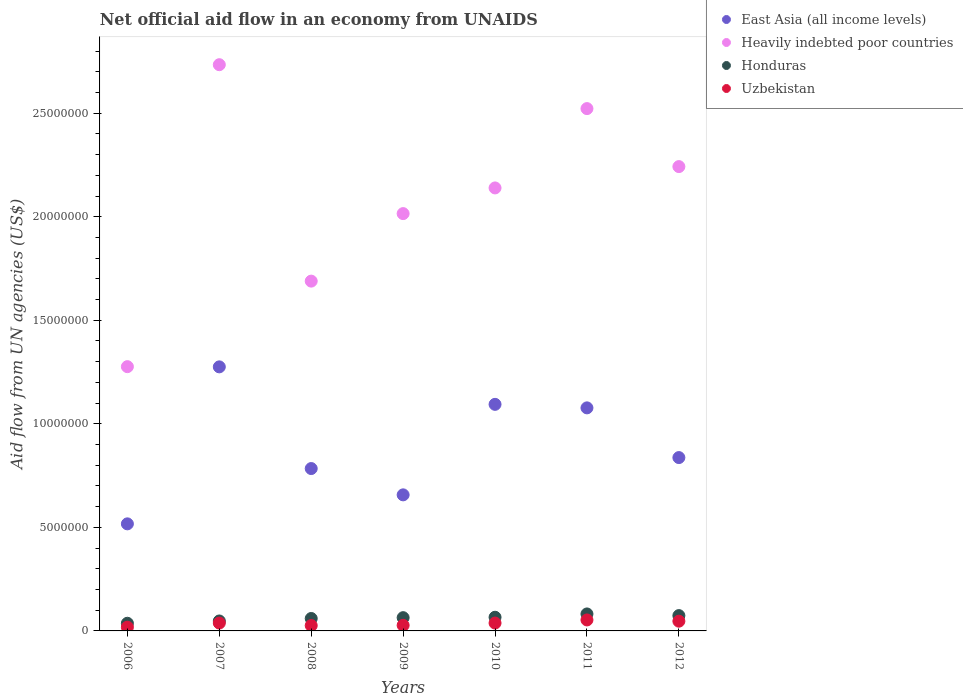Is the number of dotlines equal to the number of legend labels?
Offer a terse response. Yes. What is the net official aid flow in East Asia (all income levels) in 2008?
Offer a very short reply. 7.84e+06. Across all years, what is the maximum net official aid flow in Honduras?
Your answer should be very brief. 8.20e+05. Across all years, what is the minimum net official aid flow in Uzbekistan?
Provide a short and direct response. 1.80e+05. In which year was the net official aid flow in East Asia (all income levels) maximum?
Offer a terse response. 2007. What is the total net official aid flow in Honduras in the graph?
Your answer should be compact. 4.31e+06. What is the difference between the net official aid flow in Uzbekistan in 2008 and that in 2012?
Keep it short and to the point. -2.10e+05. What is the difference between the net official aid flow in Uzbekistan in 2011 and the net official aid flow in East Asia (all income levels) in 2009?
Your answer should be very brief. -6.04e+06. What is the average net official aid flow in Honduras per year?
Keep it short and to the point. 6.16e+05. In the year 2008, what is the difference between the net official aid flow in East Asia (all income levels) and net official aid flow in Honduras?
Ensure brevity in your answer.  7.24e+06. What is the ratio of the net official aid flow in Uzbekistan in 2010 to that in 2011?
Provide a short and direct response. 0.72. What is the difference between the highest and the lowest net official aid flow in East Asia (all income levels)?
Offer a terse response. 7.58e+06. In how many years, is the net official aid flow in Heavily indebted poor countries greater than the average net official aid flow in Heavily indebted poor countries taken over all years?
Offer a very short reply. 4. Is it the case that in every year, the sum of the net official aid flow in East Asia (all income levels) and net official aid flow in Honduras  is greater than the sum of net official aid flow in Heavily indebted poor countries and net official aid flow in Uzbekistan?
Offer a very short reply. Yes. Is it the case that in every year, the sum of the net official aid flow in Honduras and net official aid flow in East Asia (all income levels)  is greater than the net official aid flow in Uzbekistan?
Your answer should be compact. Yes. Does the net official aid flow in Heavily indebted poor countries monotonically increase over the years?
Make the answer very short. No. Is the net official aid flow in East Asia (all income levels) strictly less than the net official aid flow in Honduras over the years?
Provide a short and direct response. No. How many dotlines are there?
Offer a terse response. 4. How many years are there in the graph?
Ensure brevity in your answer.  7. Are the values on the major ticks of Y-axis written in scientific E-notation?
Provide a succinct answer. No. Does the graph contain any zero values?
Your answer should be very brief. No. Does the graph contain grids?
Give a very brief answer. No. Where does the legend appear in the graph?
Offer a very short reply. Top right. How many legend labels are there?
Your answer should be compact. 4. What is the title of the graph?
Provide a succinct answer. Net official aid flow in an economy from UNAIDS. Does "Central Europe" appear as one of the legend labels in the graph?
Keep it short and to the point. No. What is the label or title of the X-axis?
Make the answer very short. Years. What is the label or title of the Y-axis?
Offer a terse response. Aid flow from UN agencies (US$). What is the Aid flow from UN agencies (US$) in East Asia (all income levels) in 2006?
Keep it short and to the point. 5.17e+06. What is the Aid flow from UN agencies (US$) in Heavily indebted poor countries in 2006?
Your response must be concise. 1.28e+07. What is the Aid flow from UN agencies (US$) in Honduras in 2006?
Provide a succinct answer. 3.70e+05. What is the Aid flow from UN agencies (US$) in East Asia (all income levels) in 2007?
Ensure brevity in your answer.  1.28e+07. What is the Aid flow from UN agencies (US$) in Heavily indebted poor countries in 2007?
Offer a very short reply. 2.73e+07. What is the Aid flow from UN agencies (US$) in Honduras in 2007?
Your response must be concise. 4.80e+05. What is the Aid flow from UN agencies (US$) of East Asia (all income levels) in 2008?
Ensure brevity in your answer.  7.84e+06. What is the Aid flow from UN agencies (US$) in Heavily indebted poor countries in 2008?
Your answer should be compact. 1.69e+07. What is the Aid flow from UN agencies (US$) in Uzbekistan in 2008?
Ensure brevity in your answer.  2.60e+05. What is the Aid flow from UN agencies (US$) of East Asia (all income levels) in 2009?
Your response must be concise. 6.57e+06. What is the Aid flow from UN agencies (US$) of Heavily indebted poor countries in 2009?
Provide a short and direct response. 2.02e+07. What is the Aid flow from UN agencies (US$) in Honduras in 2009?
Your response must be concise. 6.40e+05. What is the Aid flow from UN agencies (US$) in Uzbekistan in 2009?
Provide a succinct answer. 2.70e+05. What is the Aid flow from UN agencies (US$) in East Asia (all income levels) in 2010?
Your answer should be compact. 1.09e+07. What is the Aid flow from UN agencies (US$) of Heavily indebted poor countries in 2010?
Provide a succinct answer. 2.14e+07. What is the Aid flow from UN agencies (US$) of Uzbekistan in 2010?
Give a very brief answer. 3.80e+05. What is the Aid flow from UN agencies (US$) in East Asia (all income levels) in 2011?
Ensure brevity in your answer.  1.08e+07. What is the Aid flow from UN agencies (US$) in Heavily indebted poor countries in 2011?
Offer a very short reply. 2.52e+07. What is the Aid flow from UN agencies (US$) in Honduras in 2011?
Your answer should be very brief. 8.20e+05. What is the Aid flow from UN agencies (US$) of Uzbekistan in 2011?
Ensure brevity in your answer.  5.30e+05. What is the Aid flow from UN agencies (US$) in East Asia (all income levels) in 2012?
Keep it short and to the point. 8.37e+06. What is the Aid flow from UN agencies (US$) of Heavily indebted poor countries in 2012?
Ensure brevity in your answer.  2.24e+07. What is the Aid flow from UN agencies (US$) of Honduras in 2012?
Provide a short and direct response. 7.40e+05. Across all years, what is the maximum Aid flow from UN agencies (US$) in East Asia (all income levels)?
Offer a terse response. 1.28e+07. Across all years, what is the maximum Aid flow from UN agencies (US$) of Heavily indebted poor countries?
Your response must be concise. 2.73e+07. Across all years, what is the maximum Aid flow from UN agencies (US$) in Honduras?
Provide a succinct answer. 8.20e+05. Across all years, what is the maximum Aid flow from UN agencies (US$) of Uzbekistan?
Provide a succinct answer. 5.30e+05. Across all years, what is the minimum Aid flow from UN agencies (US$) of East Asia (all income levels)?
Your response must be concise. 5.17e+06. Across all years, what is the minimum Aid flow from UN agencies (US$) in Heavily indebted poor countries?
Offer a very short reply. 1.28e+07. Across all years, what is the minimum Aid flow from UN agencies (US$) of Honduras?
Give a very brief answer. 3.70e+05. Across all years, what is the minimum Aid flow from UN agencies (US$) in Uzbekistan?
Give a very brief answer. 1.80e+05. What is the total Aid flow from UN agencies (US$) in East Asia (all income levels) in the graph?
Provide a succinct answer. 6.24e+07. What is the total Aid flow from UN agencies (US$) in Heavily indebted poor countries in the graph?
Provide a short and direct response. 1.46e+08. What is the total Aid flow from UN agencies (US$) of Honduras in the graph?
Give a very brief answer. 4.31e+06. What is the total Aid flow from UN agencies (US$) of Uzbekistan in the graph?
Provide a short and direct response. 2.47e+06. What is the difference between the Aid flow from UN agencies (US$) of East Asia (all income levels) in 2006 and that in 2007?
Provide a succinct answer. -7.58e+06. What is the difference between the Aid flow from UN agencies (US$) of Heavily indebted poor countries in 2006 and that in 2007?
Give a very brief answer. -1.46e+07. What is the difference between the Aid flow from UN agencies (US$) in East Asia (all income levels) in 2006 and that in 2008?
Offer a terse response. -2.67e+06. What is the difference between the Aid flow from UN agencies (US$) in Heavily indebted poor countries in 2006 and that in 2008?
Your answer should be very brief. -4.13e+06. What is the difference between the Aid flow from UN agencies (US$) of Honduras in 2006 and that in 2008?
Offer a very short reply. -2.30e+05. What is the difference between the Aid flow from UN agencies (US$) of Uzbekistan in 2006 and that in 2008?
Your answer should be compact. -8.00e+04. What is the difference between the Aid flow from UN agencies (US$) of East Asia (all income levels) in 2006 and that in 2009?
Provide a short and direct response. -1.40e+06. What is the difference between the Aid flow from UN agencies (US$) in Heavily indebted poor countries in 2006 and that in 2009?
Your answer should be compact. -7.39e+06. What is the difference between the Aid flow from UN agencies (US$) of East Asia (all income levels) in 2006 and that in 2010?
Give a very brief answer. -5.77e+06. What is the difference between the Aid flow from UN agencies (US$) of Heavily indebted poor countries in 2006 and that in 2010?
Provide a short and direct response. -8.63e+06. What is the difference between the Aid flow from UN agencies (US$) of Honduras in 2006 and that in 2010?
Provide a short and direct response. -2.90e+05. What is the difference between the Aid flow from UN agencies (US$) of East Asia (all income levels) in 2006 and that in 2011?
Your answer should be very brief. -5.60e+06. What is the difference between the Aid flow from UN agencies (US$) in Heavily indebted poor countries in 2006 and that in 2011?
Keep it short and to the point. -1.25e+07. What is the difference between the Aid flow from UN agencies (US$) in Honduras in 2006 and that in 2011?
Provide a short and direct response. -4.50e+05. What is the difference between the Aid flow from UN agencies (US$) in Uzbekistan in 2006 and that in 2011?
Your answer should be compact. -3.50e+05. What is the difference between the Aid flow from UN agencies (US$) of East Asia (all income levels) in 2006 and that in 2012?
Offer a terse response. -3.20e+06. What is the difference between the Aid flow from UN agencies (US$) in Heavily indebted poor countries in 2006 and that in 2012?
Your answer should be very brief. -9.66e+06. What is the difference between the Aid flow from UN agencies (US$) in Honduras in 2006 and that in 2012?
Provide a succinct answer. -3.70e+05. What is the difference between the Aid flow from UN agencies (US$) of East Asia (all income levels) in 2007 and that in 2008?
Your response must be concise. 4.91e+06. What is the difference between the Aid flow from UN agencies (US$) of Heavily indebted poor countries in 2007 and that in 2008?
Offer a very short reply. 1.04e+07. What is the difference between the Aid flow from UN agencies (US$) of Honduras in 2007 and that in 2008?
Offer a very short reply. -1.20e+05. What is the difference between the Aid flow from UN agencies (US$) of Uzbekistan in 2007 and that in 2008?
Provide a succinct answer. 1.20e+05. What is the difference between the Aid flow from UN agencies (US$) of East Asia (all income levels) in 2007 and that in 2009?
Give a very brief answer. 6.18e+06. What is the difference between the Aid flow from UN agencies (US$) of Heavily indebted poor countries in 2007 and that in 2009?
Provide a short and direct response. 7.19e+06. What is the difference between the Aid flow from UN agencies (US$) of Honduras in 2007 and that in 2009?
Give a very brief answer. -1.60e+05. What is the difference between the Aid flow from UN agencies (US$) of Uzbekistan in 2007 and that in 2009?
Ensure brevity in your answer.  1.10e+05. What is the difference between the Aid flow from UN agencies (US$) of East Asia (all income levels) in 2007 and that in 2010?
Provide a short and direct response. 1.81e+06. What is the difference between the Aid flow from UN agencies (US$) of Heavily indebted poor countries in 2007 and that in 2010?
Provide a short and direct response. 5.95e+06. What is the difference between the Aid flow from UN agencies (US$) in Uzbekistan in 2007 and that in 2010?
Give a very brief answer. 0. What is the difference between the Aid flow from UN agencies (US$) of East Asia (all income levels) in 2007 and that in 2011?
Keep it short and to the point. 1.98e+06. What is the difference between the Aid flow from UN agencies (US$) of Heavily indebted poor countries in 2007 and that in 2011?
Ensure brevity in your answer.  2.12e+06. What is the difference between the Aid flow from UN agencies (US$) in East Asia (all income levels) in 2007 and that in 2012?
Your response must be concise. 4.38e+06. What is the difference between the Aid flow from UN agencies (US$) in Heavily indebted poor countries in 2007 and that in 2012?
Make the answer very short. 4.92e+06. What is the difference between the Aid flow from UN agencies (US$) of Honduras in 2007 and that in 2012?
Give a very brief answer. -2.60e+05. What is the difference between the Aid flow from UN agencies (US$) of Uzbekistan in 2007 and that in 2012?
Offer a terse response. -9.00e+04. What is the difference between the Aid flow from UN agencies (US$) of East Asia (all income levels) in 2008 and that in 2009?
Offer a very short reply. 1.27e+06. What is the difference between the Aid flow from UN agencies (US$) of Heavily indebted poor countries in 2008 and that in 2009?
Provide a succinct answer. -3.26e+06. What is the difference between the Aid flow from UN agencies (US$) in East Asia (all income levels) in 2008 and that in 2010?
Offer a terse response. -3.10e+06. What is the difference between the Aid flow from UN agencies (US$) in Heavily indebted poor countries in 2008 and that in 2010?
Offer a terse response. -4.50e+06. What is the difference between the Aid flow from UN agencies (US$) in Uzbekistan in 2008 and that in 2010?
Offer a terse response. -1.20e+05. What is the difference between the Aid flow from UN agencies (US$) in East Asia (all income levels) in 2008 and that in 2011?
Provide a short and direct response. -2.93e+06. What is the difference between the Aid flow from UN agencies (US$) of Heavily indebted poor countries in 2008 and that in 2011?
Keep it short and to the point. -8.33e+06. What is the difference between the Aid flow from UN agencies (US$) in Honduras in 2008 and that in 2011?
Make the answer very short. -2.20e+05. What is the difference between the Aid flow from UN agencies (US$) in Uzbekistan in 2008 and that in 2011?
Give a very brief answer. -2.70e+05. What is the difference between the Aid flow from UN agencies (US$) in East Asia (all income levels) in 2008 and that in 2012?
Offer a very short reply. -5.30e+05. What is the difference between the Aid flow from UN agencies (US$) of Heavily indebted poor countries in 2008 and that in 2012?
Keep it short and to the point. -5.53e+06. What is the difference between the Aid flow from UN agencies (US$) in East Asia (all income levels) in 2009 and that in 2010?
Provide a succinct answer. -4.37e+06. What is the difference between the Aid flow from UN agencies (US$) in Heavily indebted poor countries in 2009 and that in 2010?
Offer a very short reply. -1.24e+06. What is the difference between the Aid flow from UN agencies (US$) of Honduras in 2009 and that in 2010?
Provide a short and direct response. -2.00e+04. What is the difference between the Aid flow from UN agencies (US$) of Uzbekistan in 2009 and that in 2010?
Your response must be concise. -1.10e+05. What is the difference between the Aid flow from UN agencies (US$) in East Asia (all income levels) in 2009 and that in 2011?
Offer a very short reply. -4.20e+06. What is the difference between the Aid flow from UN agencies (US$) in Heavily indebted poor countries in 2009 and that in 2011?
Make the answer very short. -5.07e+06. What is the difference between the Aid flow from UN agencies (US$) in Honduras in 2009 and that in 2011?
Your answer should be compact. -1.80e+05. What is the difference between the Aid flow from UN agencies (US$) of Uzbekistan in 2009 and that in 2011?
Give a very brief answer. -2.60e+05. What is the difference between the Aid flow from UN agencies (US$) of East Asia (all income levels) in 2009 and that in 2012?
Make the answer very short. -1.80e+06. What is the difference between the Aid flow from UN agencies (US$) in Heavily indebted poor countries in 2009 and that in 2012?
Offer a very short reply. -2.27e+06. What is the difference between the Aid flow from UN agencies (US$) of Honduras in 2009 and that in 2012?
Your answer should be compact. -1.00e+05. What is the difference between the Aid flow from UN agencies (US$) of Heavily indebted poor countries in 2010 and that in 2011?
Your response must be concise. -3.83e+06. What is the difference between the Aid flow from UN agencies (US$) in East Asia (all income levels) in 2010 and that in 2012?
Your answer should be compact. 2.57e+06. What is the difference between the Aid flow from UN agencies (US$) of Heavily indebted poor countries in 2010 and that in 2012?
Offer a very short reply. -1.03e+06. What is the difference between the Aid flow from UN agencies (US$) of East Asia (all income levels) in 2011 and that in 2012?
Make the answer very short. 2.40e+06. What is the difference between the Aid flow from UN agencies (US$) of Heavily indebted poor countries in 2011 and that in 2012?
Your response must be concise. 2.80e+06. What is the difference between the Aid flow from UN agencies (US$) of Uzbekistan in 2011 and that in 2012?
Provide a short and direct response. 6.00e+04. What is the difference between the Aid flow from UN agencies (US$) of East Asia (all income levels) in 2006 and the Aid flow from UN agencies (US$) of Heavily indebted poor countries in 2007?
Make the answer very short. -2.22e+07. What is the difference between the Aid flow from UN agencies (US$) of East Asia (all income levels) in 2006 and the Aid flow from UN agencies (US$) of Honduras in 2007?
Your answer should be very brief. 4.69e+06. What is the difference between the Aid flow from UN agencies (US$) in East Asia (all income levels) in 2006 and the Aid flow from UN agencies (US$) in Uzbekistan in 2007?
Give a very brief answer. 4.79e+06. What is the difference between the Aid flow from UN agencies (US$) in Heavily indebted poor countries in 2006 and the Aid flow from UN agencies (US$) in Honduras in 2007?
Your answer should be compact. 1.23e+07. What is the difference between the Aid flow from UN agencies (US$) of Heavily indebted poor countries in 2006 and the Aid flow from UN agencies (US$) of Uzbekistan in 2007?
Offer a very short reply. 1.24e+07. What is the difference between the Aid flow from UN agencies (US$) in Honduras in 2006 and the Aid flow from UN agencies (US$) in Uzbekistan in 2007?
Keep it short and to the point. -10000. What is the difference between the Aid flow from UN agencies (US$) of East Asia (all income levels) in 2006 and the Aid flow from UN agencies (US$) of Heavily indebted poor countries in 2008?
Ensure brevity in your answer.  -1.17e+07. What is the difference between the Aid flow from UN agencies (US$) in East Asia (all income levels) in 2006 and the Aid flow from UN agencies (US$) in Honduras in 2008?
Ensure brevity in your answer.  4.57e+06. What is the difference between the Aid flow from UN agencies (US$) of East Asia (all income levels) in 2006 and the Aid flow from UN agencies (US$) of Uzbekistan in 2008?
Make the answer very short. 4.91e+06. What is the difference between the Aid flow from UN agencies (US$) of Heavily indebted poor countries in 2006 and the Aid flow from UN agencies (US$) of Honduras in 2008?
Your answer should be compact. 1.22e+07. What is the difference between the Aid flow from UN agencies (US$) of Heavily indebted poor countries in 2006 and the Aid flow from UN agencies (US$) of Uzbekistan in 2008?
Your answer should be compact. 1.25e+07. What is the difference between the Aid flow from UN agencies (US$) in Honduras in 2006 and the Aid flow from UN agencies (US$) in Uzbekistan in 2008?
Ensure brevity in your answer.  1.10e+05. What is the difference between the Aid flow from UN agencies (US$) of East Asia (all income levels) in 2006 and the Aid flow from UN agencies (US$) of Heavily indebted poor countries in 2009?
Give a very brief answer. -1.50e+07. What is the difference between the Aid flow from UN agencies (US$) in East Asia (all income levels) in 2006 and the Aid flow from UN agencies (US$) in Honduras in 2009?
Offer a very short reply. 4.53e+06. What is the difference between the Aid flow from UN agencies (US$) in East Asia (all income levels) in 2006 and the Aid flow from UN agencies (US$) in Uzbekistan in 2009?
Make the answer very short. 4.90e+06. What is the difference between the Aid flow from UN agencies (US$) in Heavily indebted poor countries in 2006 and the Aid flow from UN agencies (US$) in Honduras in 2009?
Keep it short and to the point. 1.21e+07. What is the difference between the Aid flow from UN agencies (US$) of Heavily indebted poor countries in 2006 and the Aid flow from UN agencies (US$) of Uzbekistan in 2009?
Your response must be concise. 1.25e+07. What is the difference between the Aid flow from UN agencies (US$) in East Asia (all income levels) in 2006 and the Aid flow from UN agencies (US$) in Heavily indebted poor countries in 2010?
Ensure brevity in your answer.  -1.62e+07. What is the difference between the Aid flow from UN agencies (US$) of East Asia (all income levels) in 2006 and the Aid flow from UN agencies (US$) of Honduras in 2010?
Make the answer very short. 4.51e+06. What is the difference between the Aid flow from UN agencies (US$) in East Asia (all income levels) in 2006 and the Aid flow from UN agencies (US$) in Uzbekistan in 2010?
Make the answer very short. 4.79e+06. What is the difference between the Aid flow from UN agencies (US$) of Heavily indebted poor countries in 2006 and the Aid flow from UN agencies (US$) of Honduras in 2010?
Keep it short and to the point. 1.21e+07. What is the difference between the Aid flow from UN agencies (US$) in Heavily indebted poor countries in 2006 and the Aid flow from UN agencies (US$) in Uzbekistan in 2010?
Offer a very short reply. 1.24e+07. What is the difference between the Aid flow from UN agencies (US$) of Honduras in 2006 and the Aid flow from UN agencies (US$) of Uzbekistan in 2010?
Offer a terse response. -10000. What is the difference between the Aid flow from UN agencies (US$) in East Asia (all income levels) in 2006 and the Aid flow from UN agencies (US$) in Heavily indebted poor countries in 2011?
Your response must be concise. -2.00e+07. What is the difference between the Aid flow from UN agencies (US$) of East Asia (all income levels) in 2006 and the Aid flow from UN agencies (US$) of Honduras in 2011?
Ensure brevity in your answer.  4.35e+06. What is the difference between the Aid flow from UN agencies (US$) in East Asia (all income levels) in 2006 and the Aid flow from UN agencies (US$) in Uzbekistan in 2011?
Provide a succinct answer. 4.64e+06. What is the difference between the Aid flow from UN agencies (US$) in Heavily indebted poor countries in 2006 and the Aid flow from UN agencies (US$) in Honduras in 2011?
Keep it short and to the point. 1.19e+07. What is the difference between the Aid flow from UN agencies (US$) in Heavily indebted poor countries in 2006 and the Aid flow from UN agencies (US$) in Uzbekistan in 2011?
Provide a short and direct response. 1.22e+07. What is the difference between the Aid flow from UN agencies (US$) of Honduras in 2006 and the Aid flow from UN agencies (US$) of Uzbekistan in 2011?
Your response must be concise. -1.60e+05. What is the difference between the Aid flow from UN agencies (US$) of East Asia (all income levels) in 2006 and the Aid flow from UN agencies (US$) of Heavily indebted poor countries in 2012?
Your response must be concise. -1.72e+07. What is the difference between the Aid flow from UN agencies (US$) in East Asia (all income levels) in 2006 and the Aid flow from UN agencies (US$) in Honduras in 2012?
Offer a very short reply. 4.43e+06. What is the difference between the Aid flow from UN agencies (US$) in East Asia (all income levels) in 2006 and the Aid flow from UN agencies (US$) in Uzbekistan in 2012?
Your answer should be very brief. 4.70e+06. What is the difference between the Aid flow from UN agencies (US$) in Heavily indebted poor countries in 2006 and the Aid flow from UN agencies (US$) in Honduras in 2012?
Make the answer very short. 1.20e+07. What is the difference between the Aid flow from UN agencies (US$) of Heavily indebted poor countries in 2006 and the Aid flow from UN agencies (US$) of Uzbekistan in 2012?
Make the answer very short. 1.23e+07. What is the difference between the Aid flow from UN agencies (US$) of East Asia (all income levels) in 2007 and the Aid flow from UN agencies (US$) of Heavily indebted poor countries in 2008?
Ensure brevity in your answer.  -4.14e+06. What is the difference between the Aid flow from UN agencies (US$) of East Asia (all income levels) in 2007 and the Aid flow from UN agencies (US$) of Honduras in 2008?
Offer a terse response. 1.22e+07. What is the difference between the Aid flow from UN agencies (US$) in East Asia (all income levels) in 2007 and the Aid flow from UN agencies (US$) in Uzbekistan in 2008?
Your answer should be very brief. 1.25e+07. What is the difference between the Aid flow from UN agencies (US$) of Heavily indebted poor countries in 2007 and the Aid flow from UN agencies (US$) of Honduras in 2008?
Offer a terse response. 2.67e+07. What is the difference between the Aid flow from UN agencies (US$) of Heavily indebted poor countries in 2007 and the Aid flow from UN agencies (US$) of Uzbekistan in 2008?
Your response must be concise. 2.71e+07. What is the difference between the Aid flow from UN agencies (US$) in Honduras in 2007 and the Aid flow from UN agencies (US$) in Uzbekistan in 2008?
Offer a terse response. 2.20e+05. What is the difference between the Aid flow from UN agencies (US$) of East Asia (all income levels) in 2007 and the Aid flow from UN agencies (US$) of Heavily indebted poor countries in 2009?
Offer a terse response. -7.40e+06. What is the difference between the Aid flow from UN agencies (US$) of East Asia (all income levels) in 2007 and the Aid flow from UN agencies (US$) of Honduras in 2009?
Your response must be concise. 1.21e+07. What is the difference between the Aid flow from UN agencies (US$) of East Asia (all income levels) in 2007 and the Aid flow from UN agencies (US$) of Uzbekistan in 2009?
Make the answer very short. 1.25e+07. What is the difference between the Aid flow from UN agencies (US$) of Heavily indebted poor countries in 2007 and the Aid flow from UN agencies (US$) of Honduras in 2009?
Your answer should be very brief. 2.67e+07. What is the difference between the Aid flow from UN agencies (US$) in Heavily indebted poor countries in 2007 and the Aid flow from UN agencies (US$) in Uzbekistan in 2009?
Your answer should be very brief. 2.71e+07. What is the difference between the Aid flow from UN agencies (US$) in Honduras in 2007 and the Aid flow from UN agencies (US$) in Uzbekistan in 2009?
Give a very brief answer. 2.10e+05. What is the difference between the Aid flow from UN agencies (US$) of East Asia (all income levels) in 2007 and the Aid flow from UN agencies (US$) of Heavily indebted poor countries in 2010?
Ensure brevity in your answer.  -8.64e+06. What is the difference between the Aid flow from UN agencies (US$) of East Asia (all income levels) in 2007 and the Aid flow from UN agencies (US$) of Honduras in 2010?
Provide a short and direct response. 1.21e+07. What is the difference between the Aid flow from UN agencies (US$) in East Asia (all income levels) in 2007 and the Aid flow from UN agencies (US$) in Uzbekistan in 2010?
Keep it short and to the point. 1.24e+07. What is the difference between the Aid flow from UN agencies (US$) of Heavily indebted poor countries in 2007 and the Aid flow from UN agencies (US$) of Honduras in 2010?
Keep it short and to the point. 2.67e+07. What is the difference between the Aid flow from UN agencies (US$) in Heavily indebted poor countries in 2007 and the Aid flow from UN agencies (US$) in Uzbekistan in 2010?
Your answer should be compact. 2.70e+07. What is the difference between the Aid flow from UN agencies (US$) in Honduras in 2007 and the Aid flow from UN agencies (US$) in Uzbekistan in 2010?
Your answer should be compact. 1.00e+05. What is the difference between the Aid flow from UN agencies (US$) of East Asia (all income levels) in 2007 and the Aid flow from UN agencies (US$) of Heavily indebted poor countries in 2011?
Provide a short and direct response. -1.25e+07. What is the difference between the Aid flow from UN agencies (US$) in East Asia (all income levels) in 2007 and the Aid flow from UN agencies (US$) in Honduras in 2011?
Provide a succinct answer. 1.19e+07. What is the difference between the Aid flow from UN agencies (US$) of East Asia (all income levels) in 2007 and the Aid flow from UN agencies (US$) of Uzbekistan in 2011?
Provide a short and direct response. 1.22e+07. What is the difference between the Aid flow from UN agencies (US$) of Heavily indebted poor countries in 2007 and the Aid flow from UN agencies (US$) of Honduras in 2011?
Offer a very short reply. 2.65e+07. What is the difference between the Aid flow from UN agencies (US$) of Heavily indebted poor countries in 2007 and the Aid flow from UN agencies (US$) of Uzbekistan in 2011?
Make the answer very short. 2.68e+07. What is the difference between the Aid flow from UN agencies (US$) in East Asia (all income levels) in 2007 and the Aid flow from UN agencies (US$) in Heavily indebted poor countries in 2012?
Ensure brevity in your answer.  -9.67e+06. What is the difference between the Aid flow from UN agencies (US$) in East Asia (all income levels) in 2007 and the Aid flow from UN agencies (US$) in Honduras in 2012?
Make the answer very short. 1.20e+07. What is the difference between the Aid flow from UN agencies (US$) in East Asia (all income levels) in 2007 and the Aid flow from UN agencies (US$) in Uzbekistan in 2012?
Your response must be concise. 1.23e+07. What is the difference between the Aid flow from UN agencies (US$) of Heavily indebted poor countries in 2007 and the Aid flow from UN agencies (US$) of Honduras in 2012?
Offer a terse response. 2.66e+07. What is the difference between the Aid flow from UN agencies (US$) of Heavily indebted poor countries in 2007 and the Aid flow from UN agencies (US$) of Uzbekistan in 2012?
Ensure brevity in your answer.  2.69e+07. What is the difference between the Aid flow from UN agencies (US$) of East Asia (all income levels) in 2008 and the Aid flow from UN agencies (US$) of Heavily indebted poor countries in 2009?
Give a very brief answer. -1.23e+07. What is the difference between the Aid flow from UN agencies (US$) in East Asia (all income levels) in 2008 and the Aid flow from UN agencies (US$) in Honduras in 2009?
Your answer should be compact. 7.20e+06. What is the difference between the Aid flow from UN agencies (US$) in East Asia (all income levels) in 2008 and the Aid flow from UN agencies (US$) in Uzbekistan in 2009?
Your answer should be very brief. 7.57e+06. What is the difference between the Aid flow from UN agencies (US$) of Heavily indebted poor countries in 2008 and the Aid flow from UN agencies (US$) of Honduras in 2009?
Provide a short and direct response. 1.62e+07. What is the difference between the Aid flow from UN agencies (US$) in Heavily indebted poor countries in 2008 and the Aid flow from UN agencies (US$) in Uzbekistan in 2009?
Offer a very short reply. 1.66e+07. What is the difference between the Aid flow from UN agencies (US$) of East Asia (all income levels) in 2008 and the Aid flow from UN agencies (US$) of Heavily indebted poor countries in 2010?
Keep it short and to the point. -1.36e+07. What is the difference between the Aid flow from UN agencies (US$) in East Asia (all income levels) in 2008 and the Aid flow from UN agencies (US$) in Honduras in 2010?
Provide a succinct answer. 7.18e+06. What is the difference between the Aid flow from UN agencies (US$) of East Asia (all income levels) in 2008 and the Aid flow from UN agencies (US$) of Uzbekistan in 2010?
Keep it short and to the point. 7.46e+06. What is the difference between the Aid flow from UN agencies (US$) in Heavily indebted poor countries in 2008 and the Aid flow from UN agencies (US$) in Honduras in 2010?
Make the answer very short. 1.62e+07. What is the difference between the Aid flow from UN agencies (US$) in Heavily indebted poor countries in 2008 and the Aid flow from UN agencies (US$) in Uzbekistan in 2010?
Offer a terse response. 1.65e+07. What is the difference between the Aid flow from UN agencies (US$) of Honduras in 2008 and the Aid flow from UN agencies (US$) of Uzbekistan in 2010?
Your answer should be compact. 2.20e+05. What is the difference between the Aid flow from UN agencies (US$) of East Asia (all income levels) in 2008 and the Aid flow from UN agencies (US$) of Heavily indebted poor countries in 2011?
Make the answer very short. -1.74e+07. What is the difference between the Aid flow from UN agencies (US$) in East Asia (all income levels) in 2008 and the Aid flow from UN agencies (US$) in Honduras in 2011?
Your response must be concise. 7.02e+06. What is the difference between the Aid flow from UN agencies (US$) of East Asia (all income levels) in 2008 and the Aid flow from UN agencies (US$) of Uzbekistan in 2011?
Your response must be concise. 7.31e+06. What is the difference between the Aid flow from UN agencies (US$) in Heavily indebted poor countries in 2008 and the Aid flow from UN agencies (US$) in Honduras in 2011?
Your answer should be very brief. 1.61e+07. What is the difference between the Aid flow from UN agencies (US$) of Heavily indebted poor countries in 2008 and the Aid flow from UN agencies (US$) of Uzbekistan in 2011?
Provide a short and direct response. 1.64e+07. What is the difference between the Aid flow from UN agencies (US$) in Honduras in 2008 and the Aid flow from UN agencies (US$) in Uzbekistan in 2011?
Ensure brevity in your answer.  7.00e+04. What is the difference between the Aid flow from UN agencies (US$) of East Asia (all income levels) in 2008 and the Aid flow from UN agencies (US$) of Heavily indebted poor countries in 2012?
Give a very brief answer. -1.46e+07. What is the difference between the Aid flow from UN agencies (US$) of East Asia (all income levels) in 2008 and the Aid flow from UN agencies (US$) of Honduras in 2012?
Offer a very short reply. 7.10e+06. What is the difference between the Aid flow from UN agencies (US$) in East Asia (all income levels) in 2008 and the Aid flow from UN agencies (US$) in Uzbekistan in 2012?
Your answer should be compact. 7.37e+06. What is the difference between the Aid flow from UN agencies (US$) in Heavily indebted poor countries in 2008 and the Aid flow from UN agencies (US$) in Honduras in 2012?
Ensure brevity in your answer.  1.62e+07. What is the difference between the Aid flow from UN agencies (US$) in Heavily indebted poor countries in 2008 and the Aid flow from UN agencies (US$) in Uzbekistan in 2012?
Your answer should be compact. 1.64e+07. What is the difference between the Aid flow from UN agencies (US$) of East Asia (all income levels) in 2009 and the Aid flow from UN agencies (US$) of Heavily indebted poor countries in 2010?
Ensure brevity in your answer.  -1.48e+07. What is the difference between the Aid flow from UN agencies (US$) of East Asia (all income levels) in 2009 and the Aid flow from UN agencies (US$) of Honduras in 2010?
Offer a terse response. 5.91e+06. What is the difference between the Aid flow from UN agencies (US$) of East Asia (all income levels) in 2009 and the Aid flow from UN agencies (US$) of Uzbekistan in 2010?
Make the answer very short. 6.19e+06. What is the difference between the Aid flow from UN agencies (US$) of Heavily indebted poor countries in 2009 and the Aid flow from UN agencies (US$) of Honduras in 2010?
Keep it short and to the point. 1.95e+07. What is the difference between the Aid flow from UN agencies (US$) in Heavily indebted poor countries in 2009 and the Aid flow from UN agencies (US$) in Uzbekistan in 2010?
Offer a terse response. 1.98e+07. What is the difference between the Aid flow from UN agencies (US$) of Honduras in 2009 and the Aid flow from UN agencies (US$) of Uzbekistan in 2010?
Ensure brevity in your answer.  2.60e+05. What is the difference between the Aid flow from UN agencies (US$) in East Asia (all income levels) in 2009 and the Aid flow from UN agencies (US$) in Heavily indebted poor countries in 2011?
Make the answer very short. -1.86e+07. What is the difference between the Aid flow from UN agencies (US$) of East Asia (all income levels) in 2009 and the Aid flow from UN agencies (US$) of Honduras in 2011?
Offer a very short reply. 5.75e+06. What is the difference between the Aid flow from UN agencies (US$) in East Asia (all income levels) in 2009 and the Aid flow from UN agencies (US$) in Uzbekistan in 2011?
Your answer should be compact. 6.04e+06. What is the difference between the Aid flow from UN agencies (US$) in Heavily indebted poor countries in 2009 and the Aid flow from UN agencies (US$) in Honduras in 2011?
Provide a short and direct response. 1.93e+07. What is the difference between the Aid flow from UN agencies (US$) of Heavily indebted poor countries in 2009 and the Aid flow from UN agencies (US$) of Uzbekistan in 2011?
Ensure brevity in your answer.  1.96e+07. What is the difference between the Aid flow from UN agencies (US$) in Honduras in 2009 and the Aid flow from UN agencies (US$) in Uzbekistan in 2011?
Make the answer very short. 1.10e+05. What is the difference between the Aid flow from UN agencies (US$) in East Asia (all income levels) in 2009 and the Aid flow from UN agencies (US$) in Heavily indebted poor countries in 2012?
Your answer should be compact. -1.58e+07. What is the difference between the Aid flow from UN agencies (US$) of East Asia (all income levels) in 2009 and the Aid flow from UN agencies (US$) of Honduras in 2012?
Offer a very short reply. 5.83e+06. What is the difference between the Aid flow from UN agencies (US$) in East Asia (all income levels) in 2009 and the Aid flow from UN agencies (US$) in Uzbekistan in 2012?
Your answer should be compact. 6.10e+06. What is the difference between the Aid flow from UN agencies (US$) in Heavily indebted poor countries in 2009 and the Aid flow from UN agencies (US$) in Honduras in 2012?
Your response must be concise. 1.94e+07. What is the difference between the Aid flow from UN agencies (US$) in Heavily indebted poor countries in 2009 and the Aid flow from UN agencies (US$) in Uzbekistan in 2012?
Provide a short and direct response. 1.97e+07. What is the difference between the Aid flow from UN agencies (US$) of East Asia (all income levels) in 2010 and the Aid flow from UN agencies (US$) of Heavily indebted poor countries in 2011?
Provide a short and direct response. -1.43e+07. What is the difference between the Aid flow from UN agencies (US$) of East Asia (all income levels) in 2010 and the Aid flow from UN agencies (US$) of Honduras in 2011?
Offer a terse response. 1.01e+07. What is the difference between the Aid flow from UN agencies (US$) in East Asia (all income levels) in 2010 and the Aid flow from UN agencies (US$) in Uzbekistan in 2011?
Your answer should be very brief. 1.04e+07. What is the difference between the Aid flow from UN agencies (US$) of Heavily indebted poor countries in 2010 and the Aid flow from UN agencies (US$) of Honduras in 2011?
Your answer should be compact. 2.06e+07. What is the difference between the Aid flow from UN agencies (US$) in Heavily indebted poor countries in 2010 and the Aid flow from UN agencies (US$) in Uzbekistan in 2011?
Keep it short and to the point. 2.09e+07. What is the difference between the Aid flow from UN agencies (US$) of East Asia (all income levels) in 2010 and the Aid flow from UN agencies (US$) of Heavily indebted poor countries in 2012?
Ensure brevity in your answer.  -1.15e+07. What is the difference between the Aid flow from UN agencies (US$) of East Asia (all income levels) in 2010 and the Aid flow from UN agencies (US$) of Honduras in 2012?
Provide a succinct answer. 1.02e+07. What is the difference between the Aid flow from UN agencies (US$) of East Asia (all income levels) in 2010 and the Aid flow from UN agencies (US$) of Uzbekistan in 2012?
Offer a terse response. 1.05e+07. What is the difference between the Aid flow from UN agencies (US$) of Heavily indebted poor countries in 2010 and the Aid flow from UN agencies (US$) of Honduras in 2012?
Your answer should be compact. 2.06e+07. What is the difference between the Aid flow from UN agencies (US$) of Heavily indebted poor countries in 2010 and the Aid flow from UN agencies (US$) of Uzbekistan in 2012?
Provide a short and direct response. 2.09e+07. What is the difference between the Aid flow from UN agencies (US$) of Honduras in 2010 and the Aid flow from UN agencies (US$) of Uzbekistan in 2012?
Keep it short and to the point. 1.90e+05. What is the difference between the Aid flow from UN agencies (US$) in East Asia (all income levels) in 2011 and the Aid flow from UN agencies (US$) in Heavily indebted poor countries in 2012?
Give a very brief answer. -1.16e+07. What is the difference between the Aid flow from UN agencies (US$) of East Asia (all income levels) in 2011 and the Aid flow from UN agencies (US$) of Honduras in 2012?
Provide a succinct answer. 1.00e+07. What is the difference between the Aid flow from UN agencies (US$) in East Asia (all income levels) in 2011 and the Aid flow from UN agencies (US$) in Uzbekistan in 2012?
Offer a terse response. 1.03e+07. What is the difference between the Aid flow from UN agencies (US$) in Heavily indebted poor countries in 2011 and the Aid flow from UN agencies (US$) in Honduras in 2012?
Offer a terse response. 2.45e+07. What is the difference between the Aid flow from UN agencies (US$) of Heavily indebted poor countries in 2011 and the Aid flow from UN agencies (US$) of Uzbekistan in 2012?
Provide a succinct answer. 2.48e+07. What is the difference between the Aid flow from UN agencies (US$) in Honduras in 2011 and the Aid flow from UN agencies (US$) in Uzbekistan in 2012?
Ensure brevity in your answer.  3.50e+05. What is the average Aid flow from UN agencies (US$) of East Asia (all income levels) per year?
Keep it short and to the point. 8.92e+06. What is the average Aid flow from UN agencies (US$) of Heavily indebted poor countries per year?
Provide a succinct answer. 2.09e+07. What is the average Aid flow from UN agencies (US$) of Honduras per year?
Give a very brief answer. 6.16e+05. What is the average Aid flow from UN agencies (US$) in Uzbekistan per year?
Provide a short and direct response. 3.53e+05. In the year 2006, what is the difference between the Aid flow from UN agencies (US$) of East Asia (all income levels) and Aid flow from UN agencies (US$) of Heavily indebted poor countries?
Offer a terse response. -7.59e+06. In the year 2006, what is the difference between the Aid flow from UN agencies (US$) of East Asia (all income levels) and Aid flow from UN agencies (US$) of Honduras?
Keep it short and to the point. 4.80e+06. In the year 2006, what is the difference between the Aid flow from UN agencies (US$) in East Asia (all income levels) and Aid flow from UN agencies (US$) in Uzbekistan?
Give a very brief answer. 4.99e+06. In the year 2006, what is the difference between the Aid flow from UN agencies (US$) of Heavily indebted poor countries and Aid flow from UN agencies (US$) of Honduras?
Give a very brief answer. 1.24e+07. In the year 2006, what is the difference between the Aid flow from UN agencies (US$) of Heavily indebted poor countries and Aid flow from UN agencies (US$) of Uzbekistan?
Ensure brevity in your answer.  1.26e+07. In the year 2007, what is the difference between the Aid flow from UN agencies (US$) of East Asia (all income levels) and Aid flow from UN agencies (US$) of Heavily indebted poor countries?
Offer a very short reply. -1.46e+07. In the year 2007, what is the difference between the Aid flow from UN agencies (US$) in East Asia (all income levels) and Aid flow from UN agencies (US$) in Honduras?
Keep it short and to the point. 1.23e+07. In the year 2007, what is the difference between the Aid flow from UN agencies (US$) in East Asia (all income levels) and Aid flow from UN agencies (US$) in Uzbekistan?
Make the answer very short. 1.24e+07. In the year 2007, what is the difference between the Aid flow from UN agencies (US$) in Heavily indebted poor countries and Aid flow from UN agencies (US$) in Honduras?
Your answer should be compact. 2.69e+07. In the year 2007, what is the difference between the Aid flow from UN agencies (US$) in Heavily indebted poor countries and Aid flow from UN agencies (US$) in Uzbekistan?
Your answer should be compact. 2.70e+07. In the year 2007, what is the difference between the Aid flow from UN agencies (US$) of Honduras and Aid flow from UN agencies (US$) of Uzbekistan?
Offer a terse response. 1.00e+05. In the year 2008, what is the difference between the Aid flow from UN agencies (US$) of East Asia (all income levels) and Aid flow from UN agencies (US$) of Heavily indebted poor countries?
Offer a very short reply. -9.05e+06. In the year 2008, what is the difference between the Aid flow from UN agencies (US$) in East Asia (all income levels) and Aid flow from UN agencies (US$) in Honduras?
Make the answer very short. 7.24e+06. In the year 2008, what is the difference between the Aid flow from UN agencies (US$) of East Asia (all income levels) and Aid flow from UN agencies (US$) of Uzbekistan?
Your answer should be compact. 7.58e+06. In the year 2008, what is the difference between the Aid flow from UN agencies (US$) in Heavily indebted poor countries and Aid flow from UN agencies (US$) in Honduras?
Make the answer very short. 1.63e+07. In the year 2008, what is the difference between the Aid flow from UN agencies (US$) of Heavily indebted poor countries and Aid flow from UN agencies (US$) of Uzbekistan?
Offer a terse response. 1.66e+07. In the year 2008, what is the difference between the Aid flow from UN agencies (US$) of Honduras and Aid flow from UN agencies (US$) of Uzbekistan?
Your answer should be very brief. 3.40e+05. In the year 2009, what is the difference between the Aid flow from UN agencies (US$) in East Asia (all income levels) and Aid flow from UN agencies (US$) in Heavily indebted poor countries?
Your answer should be compact. -1.36e+07. In the year 2009, what is the difference between the Aid flow from UN agencies (US$) in East Asia (all income levels) and Aid flow from UN agencies (US$) in Honduras?
Your response must be concise. 5.93e+06. In the year 2009, what is the difference between the Aid flow from UN agencies (US$) of East Asia (all income levels) and Aid flow from UN agencies (US$) of Uzbekistan?
Your answer should be very brief. 6.30e+06. In the year 2009, what is the difference between the Aid flow from UN agencies (US$) of Heavily indebted poor countries and Aid flow from UN agencies (US$) of Honduras?
Your answer should be very brief. 1.95e+07. In the year 2009, what is the difference between the Aid flow from UN agencies (US$) of Heavily indebted poor countries and Aid flow from UN agencies (US$) of Uzbekistan?
Make the answer very short. 1.99e+07. In the year 2010, what is the difference between the Aid flow from UN agencies (US$) of East Asia (all income levels) and Aid flow from UN agencies (US$) of Heavily indebted poor countries?
Offer a very short reply. -1.04e+07. In the year 2010, what is the difference between the Aid flow from UN agencies (US$) of East Asia (all income levels) and Aid flow from UN agencies (US$) of Honduras?
Provide a short and direct response. 1.03e+07. In the year 2010, what is the difference between the Aid flow from UN agencies (US$) in East Asia (all income levels) and Aid flow from UN agencies (US$) in Uzbekistan?
Offer a very short reply. 1.06e+07. In the year 2010, what is the difference between the Aid flow from UN agencies (US$) of Heavily indebted poor countries and Aid flow from UN agencies (US$) of Honduras?
Keep it short and to the point. 2.07e+07. In the year 2010, what is the difference between the Aid flow from UN agencies (US$) of Heavily indebted poor countries and Aid flow from UN agencies (US$) of Uzbekistan?
Your answer should be compact. 2.10e+07. In the year 2011, what is the difference between the Aid flow from UN agencies (US$) of East Asia (all income levels) and Aid flow from UN agencies (US$) of Heavily indebted poor countries?
Provide a short and direct response. -1.44e+07. In the year 2011, what is the difference between the Aid flow from UN agencies (US$) in East Asia (all income levels) and Aid flow from UN agencies (US$) in Honduras?
Provide a short and direct response. 9.95e+06. In the year 2011, what is the difference between the Aid flow from UN agencies (US$) in East Asia (all income levels) and Aid flow from UN agencies (US$) in Uzbekistan?
Provide a succinct answer. 1.02e+07. In the year 2011, what is the difference between the Aid flow from UN agencies (US$) in Heavily indebted poor countries and Aid flow from UN agencies (US$) in Honduras?
Provide a short and direct response. 2.44e+07. In the year 2011, what is the difference between the Aid flow from UN agencies (US$) of Heavily indebted poor countries and Aid flow from UN agencies (US$) of Uzbekistan?
Keep it short and to the point. 2.47e+07. In the year 2011, what is the difference between the Aid flow from UN agencies (US$) of Honduras and Aid flow from UN agencies (US$) of Uzbekistan?
Provide a short and direct response. 2.90e+05. In the year 2012, what is the difference between the Aid flow from UN agencies (US$) in East Asia (all income levels) and Aid flow from UN agencies (US$) in Heavily indebted poor countries?
Give a very brief answer. -1.40e+07. In the year 2012, what is the difference between the Aid flow from UN agencies (US$) in East Asia (all income levels) and Aid flow from UN agencies (US$) in Honduras?
Your answer should be very brief. 7.63e+06. In the year 2012, what is the difference between the Aid flow from UN agencies (US$) in East Asia (all income levels) and Aid flow from UN agencies (US$) in Uzbekistan?
Your answer should be very brief. 7.90e+06. In the year 2012, what is the difference between the Aid flow from UN agencies (US$) of Heavily indebted poor countries and Aid flow from UN agencies (US$) of Honduras?
Offer a terse response. 2.17e+07. In the year 2012, what is the difference between the Aid flow from UN agencies (US$) in Heavily indebted poor countries and Aid flow from UN agencies (US$) in Uzbekistan?
Offer a terse response. 2.20e+07. In the year 2012, what is the difference between the Aid flow from UN agencies (US$) in Honduras and Aid flow from UN agencies (US$) in Uzbekistan?
Provide a succinct answer. 2.70e+05. What is the ratio of the Aid flow from UN agencies (US$) in East Asia (all income levels) in 2006 to that in 2007?
Provide a succinct answer. 0.41. What is the ratio of the Aid flow from UN agencies (US$) in Heavily indebted poor countries in 2006 to that in 2007?
Your response must be concise. 0.47. What is the ratio of the Aid flow from UN agencies (US$) of Honduras in 2006 to that in 2007?
Your answer should be compact. 0.77. What is the ratio of the Aid flow from UN agencies (US$) of Uzbekistan in 2006 to that in 2007?
Offer a very short reply. 0.47. What is the ratio of the Aid flow from UN agencies (US$) of East Asia (all income levels) in 2006 to that in 2008?
Offer a very short reply. 0.66. What is the ratio of the Aid flow from UN agencies (US$) in Heavily indebted poor countries in 2006 to that in 2008?
Your response must be concise. 0.76. What is the ratio of the Aid flow from UN agencies (US$) of Honduras in 2006 to that in 2008?
Your answer should be compact. 0.62. What is the ratio of the Aid flow from UN agencies (US$) of Uzbekistan in 2006 to that in 2008?
Your response must be concise. 0.69. What is the ratio of the Aid flow from UN agencies (US$) of East Asia (all income levels) in 2006 to that in 2009?
Offer a very short reply. 0.79. What is the ratio of the Aid flow from UN agencies (US$) in Heavily indebted poor countries in 2006 to that in 2009?
Make the answer very short. 0.63. What is the ratio of the Aid flow from UN agencies (US$) in Honduras in 2006 to that in 2009?
Ensure brevity in your answer.  0.58. What is the ratio of the Aid flow from UN agencies (US$) in East Asia (all income levels) in 2006 to that in 2010?
Ensure brevity in your answer.  0.47. What is the ratio of the Aid flow from UN agencies (US$) of Heavily indebted poor countries in 2006 to that in 2010?
Offer a terse response. 0.6. What is the ratio of the Aid flow from UN agencies (US$) of Honduras in 2006 to that in 2010?
Your answer should be compact. 0.56. What is the ratio of the Aid flow from UN agencies (US$) of Uzbekistan in 2006 to that in 2010?
Provide a short and direct response. 0.47. What is the ratio of the Aid flow from UN agencies (US$) of East Asia (all income levels) in 2006 to that in 2011?
Keep it short and to the point. 0.48. What is the ratio of the Aid flow from UN agencies (US$) in Heavily indebted poor countries in 2006 to that in 2011?
Provide a short and direct response. 0.51. What is the ratio of the Aid flow from UN agencies (US$) of Honduras in 2006 to that in 2011?
Provide a succinct answer. 0.45. What is the ratio of the Aid flow from UN agencies (US$) in Uzbekistan in 2006 to that in 2011?
Offer a very short reply. 0.34. What is the ratio of the Aid flow from UN agencies (US$) of East Asia (all income levels) in 2006 to that in 2012?
Keep it short and to the point. 0.62. What is the ratio of the Aid flow from UN agencies (US$) in Heavily indebted poor countries in 2006 to that in 2012?
Make the answer very short. 0.57. What is the ratio of the Aid flow from UN agencies (US$) in Uzbekistan in 2006 to that in 2012?
Provide a short and direct response. 0.38. What is the ratio of the Aid flow from UN agencies (US$) in East Asia (all income levels) in 2007 to that in 2008?
Give a very brief answer. 1.63. What is the ratio of the Aid flow from UN agencies (US$) of Heavily indebted poor countries in 2007 to that in 2008?
Give a very brief answer. 1.62. What is the ratio of the Aid flow from UN agencies (US$) of Honduras in 2007 to that in 2008?
Keep it short and to the point. 0.8. What is the ratio of the Aid flow from UN agencies (US$) of Uzbekistan in 2007 to that in 2008?
Provide a succinct answer. 1.46. What is the ratio of the Aid flow from UN agencies (US$) of East Asia (all income levels) in 2007 to that in 2009?
Provide a succinct answer. 1.94. What is the ratio of the Aid flow from UN agencies (US$) in Heavily indebted poor countries in 2007 to that in 2009?
Make the answer very short. 1.36. What is the ratio of the Aid flow from UN agencies (US$) of Uzbekistan in 2007 to that in 2009?
Your answer should be compact. 1.41. What is the ratio of the Aid flow from UN agencies (US$) in East Asia (all income levels) in 2007 to that in 2010?
Give a very brief answer. 1.17. What is the ratio of the Aid flow from UN agencies (US$) of Heavily indebted poor countries in 2007 to that in 2010?
Give a very brief answer. 1.28. What is the ratio of the Aid flow from UN agencies (US$) in Honduras in 2007 to that in 2010?
Offer a terse response. 0.73. What is the ratio of the Aid flow from UN agencies (US$) of East Asia (all income levels) in 2007 to that in 2011?
Offer a very short reply. 1.18. What is the ratio of the Aid flow from UN agencies (US$) in Heavily indebted poor countries in 2007 to that in 2011?
Offer a terse response. 1.08. What is the ratio of the Aid flow from UN agencies (US$) of Honduras in 2007 to that in 2011?
Offer a very short reply. 0.59. What is the ratio of the Aid flow from UN agencies (US$) of Uzbekistan in 2007 to that in 2011?
Your answer should be compact. 0.72. What is the ratio of the Aid flow from UN agencies (US$) of East Asia (all income levels) in 2007 to that in 2012?
Your answer should be very brief. 1.52. What is the ratio of the Aid flow from UN agencies (US$) of Heavily indebted poor countries in 2007 to that in 2012?
Your response must be concise. 1.22. What is the ratio of the Aid flow from UN agencies (US$) in Honduras in 2007 to that in 2012?
Make the answer very short. 0.65. What is the ratio of the Aid flow from UN agencies (US$) in Uzbekistan in 2007 to that in 2012?
Provide a short and direct response. 0.81. What is the ratio of the Aid flow from UN agencies (US$) in East Asia (all income levels) in 2008 to that in 2009?
Provide a succinct answer. 1.19. What is the ratio of the Aid flow from UN agencies (US$) in Heavily indebted poor countries in 2008 to that in 2009?
Offer a very short reply. 0.84. What is the ratio of the Aid flow from UN agencies (US$) of East Asia (all income levels) in 2008 to that in 2010?
Your answer should be compact. 0.72. What is the ratio of the Aid flow from UN agencies (US$) of Heavily indebted poor countries in 2008 to that in 2010?
Offer a very short reply. 0.79. What is the ratio of the Aid flow from UN agencies (US$) of Honduras in 2008 to that in 2010?
Keep it short and to the point. 0.91. What is the ratio of the Aid flow from UN agencies (US$) in Uzbekistan in 2008 to that in 2010?
Offer a terse response. 0.68. What is the ratio of the Aid flow from UN agencies (US$) of East Asia (all income levels) in 2008 to that in 2011?
Make the answer very short. 0.73. What is the ratio of the Aid flow from UN agencies (US$) of Heavily indebted poor countries in 2008 to that in 2011?
Provide a short and direct response. 0.67. What is the ratio of the Aid flow from UN agencies (US$) of Honduras in 2008 to that in 2011?
Offer a terse response. 0.73. What is the ratio of the Aid flow from UN agencies (US$) of Uzbekistan in 2008 to that in 2011?
Ensure brevity in your answer.  0.49. What is the ratio of the Aid flow from UN agencies (US$) in East Asia (all income levels) in 2008 to that in 2012?
Keep it short and to the point. 0.94. What is the ratio of the Aid flow from UN agencies (US$) of Heavily indebted poor countries in 2008 to that in 2012?
Provide a succinct answer. 0.75. What is the ratio of the Aid flow from UN agencies (US$) in Honduras in 2008 to that in 2012?
Offer a very short reply. 0.81. What is the ratio of the Aid flow from UN agencies (US$) of Uzbekistan in 2008 to that in 2012?
Keep it short and to the point. 0.55. What is the ratio of the Aid flow from UN agencies (US$) in East Asia (all income levels) in 2009 to that in 2010?
Make the answer very short. 0.6. What is the ratio of the Aid flow from UN agencies (US$) of Heavily indebted poor countries in 2009 to that in 2010?
Your answer should be compact. 0.94. What is the ratio of the Aid flow from UN agencies (US$) of Honduras in 2009 to that in 2010?
Keep it short and to the point. 0.97. What is the ratio of the Aid flow from UN agencies (US$) of Uzbekistan in 2009 to that in 2010?
Give a very brief answer. 0.71. What is the ratio of the Aid flow from UN agencies (US$) in East Asia (all income levels) in 2009 to that in 2011?
Offer a terse response. 0.61. What is the ratio of the Aid flow from UN agencies (US$) of Heavily indebted poor countries in 2009 to that in 2011?
Keep it short and to the point. 0.8. What is the ratio of the Aid flow from UN agencies (US$) in Honduras in 2009 to that in 2011?
Your answer should be compact. 0.78. What is the ratio of the Aid flow from UN agencies (US$) in Uzbekistan in 2009 to that in 2011?
Give a very brief answer. 0.51. What is the ratio of the Aid flow from UN agencies (US$) in East Asia (all income levels) in 2009 to that in 2012?
Your answer should be very brief. 0.78. What is the ratio of the Aid flow from UN agencies (US$) of Heavily indebted poor countries in 2009 to that in 2012?
Your response must be concise. 0.9. What is the ratio of the Aid flow from UN agencies (US$) of Honduras in 2009 to that in 2012?
Your answer should be very brief. 0.86. What is the ratio of the Aid flow from UN agencies (US$) of Uzbekistan in 2009 to that in 2012?
Give a very brief answer. 0.57. What is the ratio of the Aid flow from UN agencies (US$) in East Asia (all income levels) in 2010 to that in 2011?
Offer a very short reply. 1.02. What is the ratio of the Aid flow from UN agencies (US$) in Heavily indebted poor countries in 2010 to that in 2011?
Keep it short and to the point. 0.85. What is the ratio of the Aid flow from UN agencies (US$) in Honduras in 2010 to that in 2011?
Give a very brief answer. 0.8. What is the ratio of the Aid flow from UN agencies (US$) in Uzbekistan in 2010 to that in 2011?
Offer a terse response. 0.72. What is the ratio of the Aid flow from UN agencies (US$) in East Asia (all income levels) in 2010 to that in 2012?
Give a very brief answer. 1.31. What is the ratio of the Aid flow from UN agencies (US$) of Heavily indebted poor countries in 2010 to that in 2012?
Provide a short and direct response. 0.95. What is the ratio of the Aid flow from UN agencies (US$) of Honduras in 2010 to that in 2012?
Your response must be concise. 0.89. What is the ratio of the Aid flow from UN agencies (US$) in Uzbekistan in 2010 to that in 2012?
Ensure brevity in your answer.  0.81. What is the ratio of the Aid flow from UN agencies (US$) in East Asia (all income levels) in 2011 to that in 2012?
Your answer should be very brief. 1.29. What is the ratio of the Aid flow from UN agencies (US$) in Heavily indebted poor countries in 2011 to that in 2012?
Make the answer very short. 1.12. What is the ratio of the Aid flow from UN agencies (US$) of Honduras in 2011 to that in 2012?
Make the answer very short. 1.11. What is the ratio of the Aid flow from UN agencies (US$) of Uzbekistan in 2011 to that in 2012?
Provide a succinct answer. 1.13. What is the difference between the highest and the second highest Aid flow from UN agencies (US$) of East Asia (all income levels)?
Offer a terse response. 1.81e+06. What is the difference between the highest and the second highest Aid flow from UN agencies (US$) of Heavily indebted poor countries?
Your response must be concise. 2.12e+06. What is the difference between the highest and the second highest Aid flow from UN agencies (US$) in Honduras?
Give a very brief answer. 8.00e+04. What is the difference between the highest and the second highest Aid flow from UN agencies (US$) of Uzbekistan?
Give a very brief answer. 6.00e+04. What is the difference between the highest and the lowest Aid flow from UN agencies (US$) in East Asia (all income levels)?
Offer a very short reply. 7.58e+06. What is the difference between the highest and the lowest Aid flow from UN agencies (US$) of Heavily indebted poor countries?
Provide a short and direct response. 1.46e+07. 